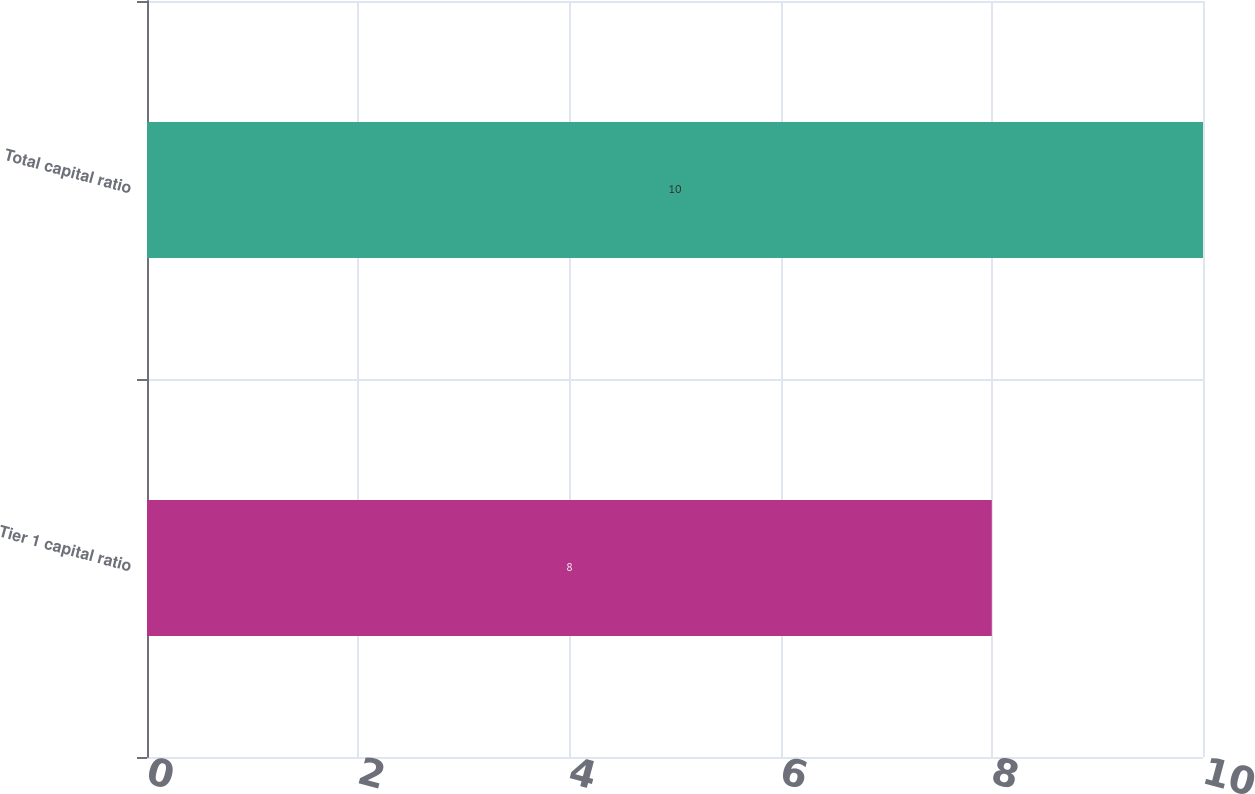Convert chart. <chart><loc_0><loc_0><loc_500><loc_500><bar_chart><fcel>Tier 1 capital ratio<fcel>Total capital ratio<nl><fcel>8<fcel>10<nl></chart> 